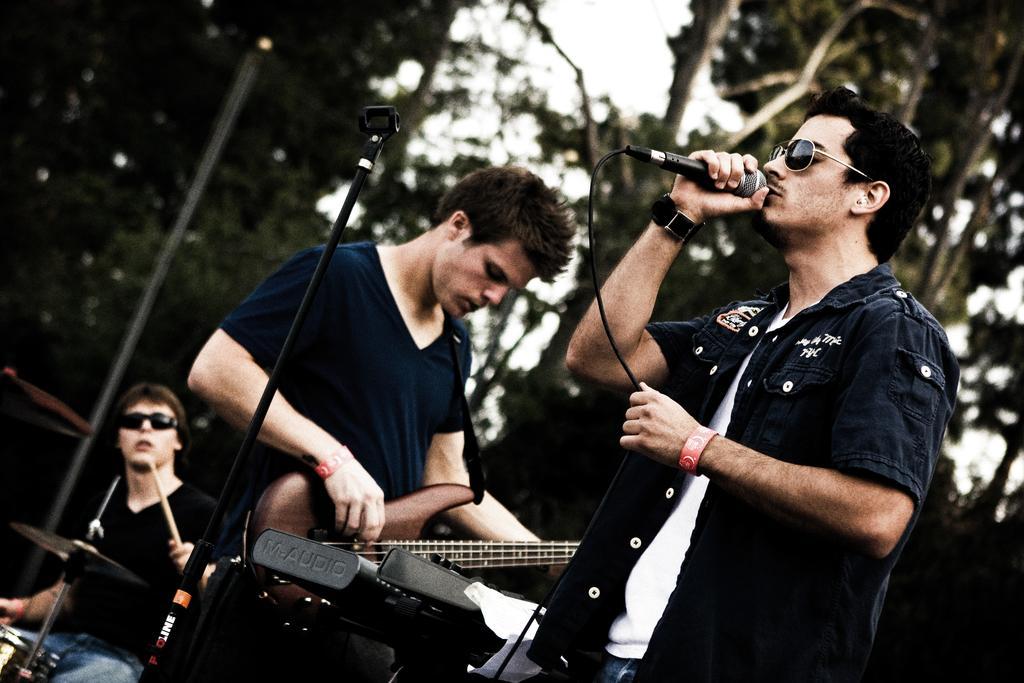Describe this image in one or two sentences. Three persons are standing and one person is holding a microphone is just singing and the other person is playing a guitar and the third person is playing at drumsticks at the back side we can see some trees. 